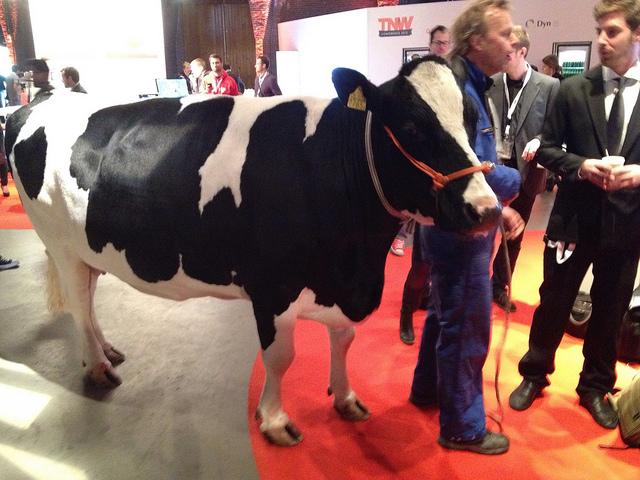Is this a livestock auction?
Give a very brief answer. Yes. Has the cow been tagged?
Write a very short answer. Yes. Is this a holstein?
Short answer required. Yes. 